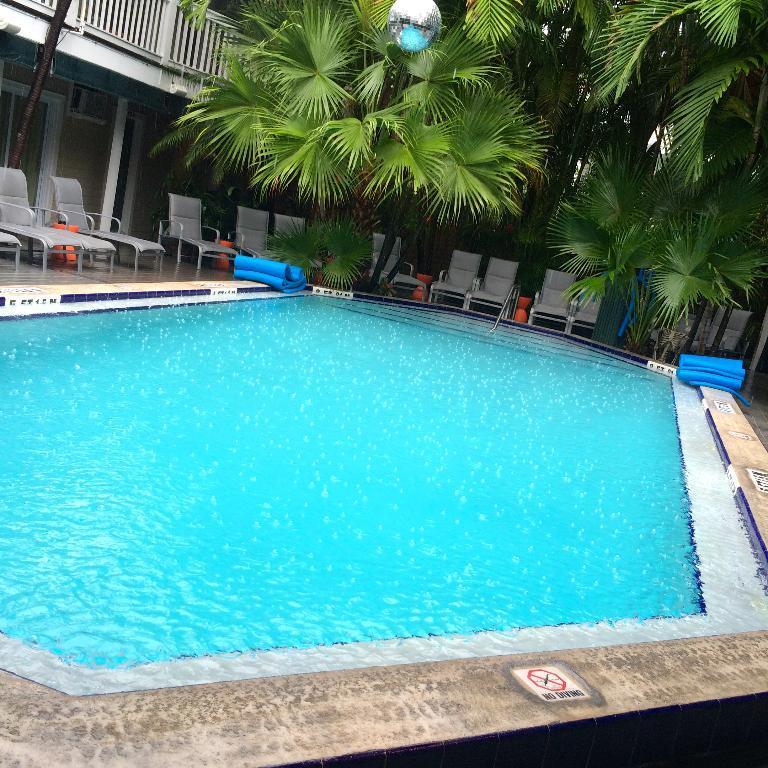Please provide a concise description of this image. In this image we can see a swimming pool. We can also see a signboard, some carpets and chairs beside the pool. We can also a building with the railing, some poles, a street lamp and a group of trees. 